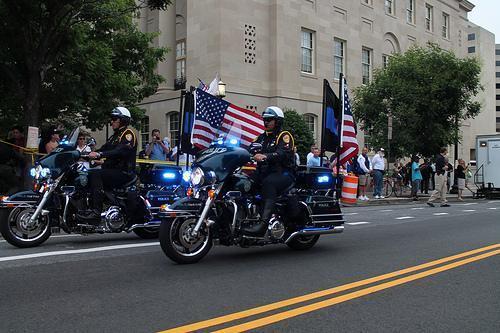How many officers on the motorcycles?
Give a very brief answer. 2. 